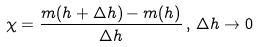<formula> <loc_0><loc_0><loc_500><loc_500>\chi = \frac { m ( h + \Delta h ) - m ( h ) } { \Delta h } \, , \, \Delta h \rightarrow 0</formula> 